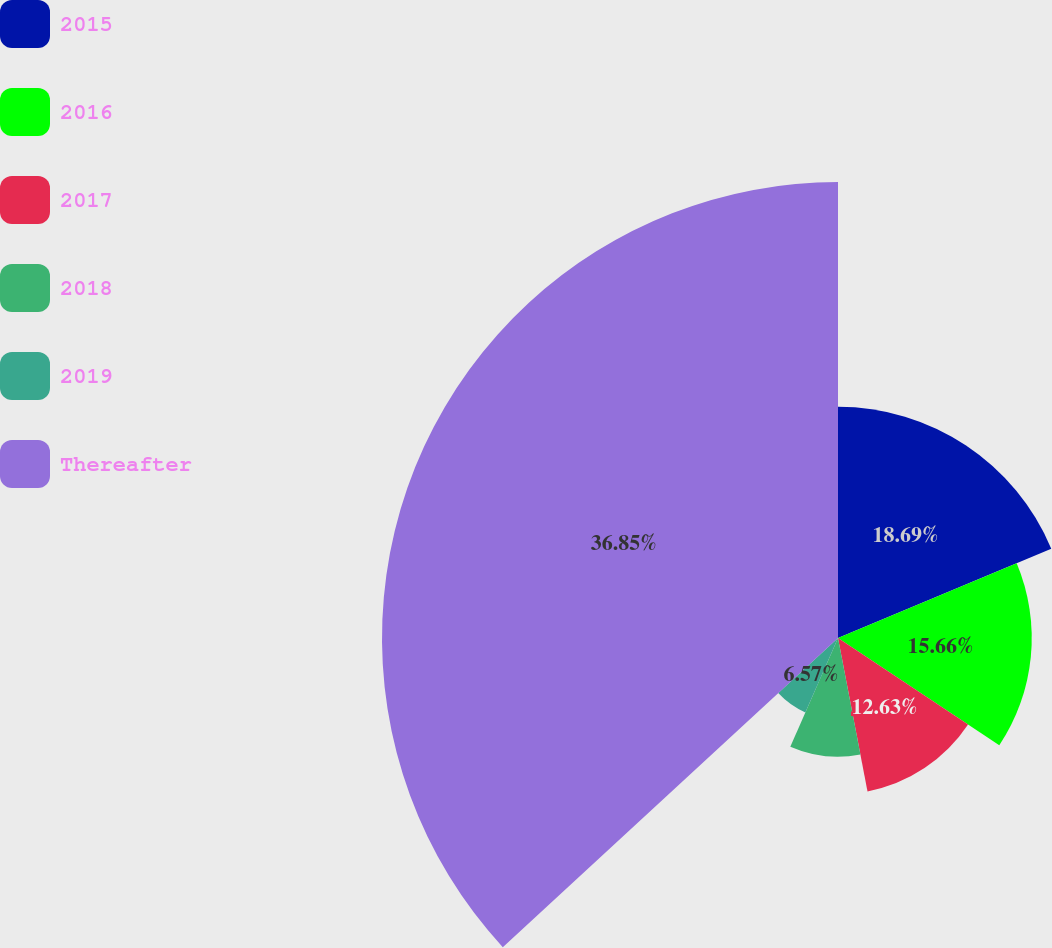Convert chart to OTSL. <chart><loc_0><loc_0><loc_500><loc_500><pie_chart><fcel>2015<fcel>2016<fcel>2017<fcel>2018<fcel>2019<fcel>Thereafter<nl><fcel>18.69%<fcel>15.66%<fcel>12.63%<fcel>9.6%<fcel>6.57%<fcel>36.86%<nl></chart> 